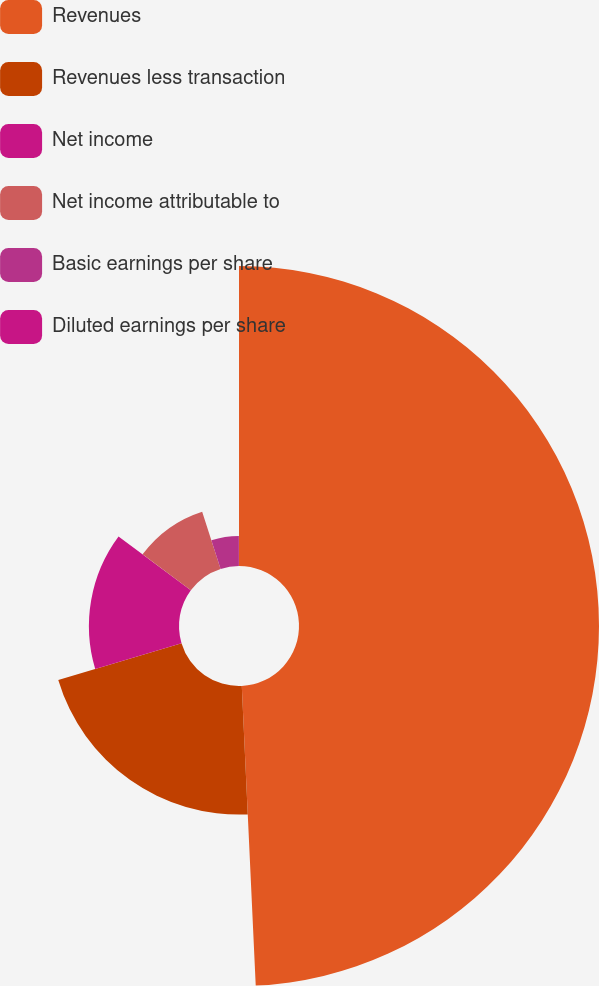Convert chart to OTSL. <chart><loc_0><loc_0><loc_500><loc_500><pie_chart><fcel>Revenues<fcel>Revenues less transaction<fcel>Net income<fcel>Net income attributable to<fcel>Basic earnings per share<fcel>Diluted earnings per share<nl><fcel>49.26%<fcel>21.12%<fcel>14.79%<fcel>9.87%<fcel>4.94%<fcel>0.02%<nl></chart> 